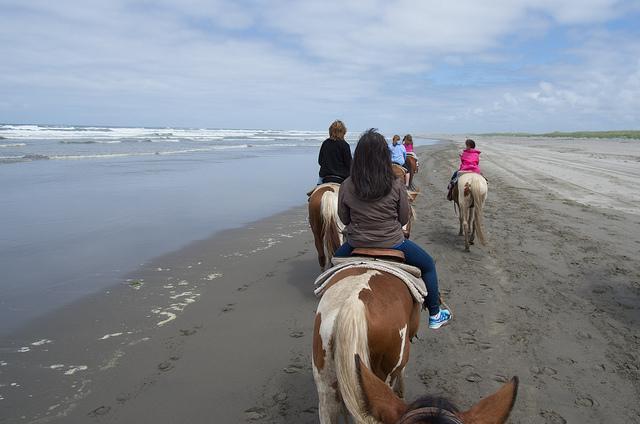How many people do you see?
Give a very brief answer. 5. How many horses are there?
Give a very brief answer. 2. 